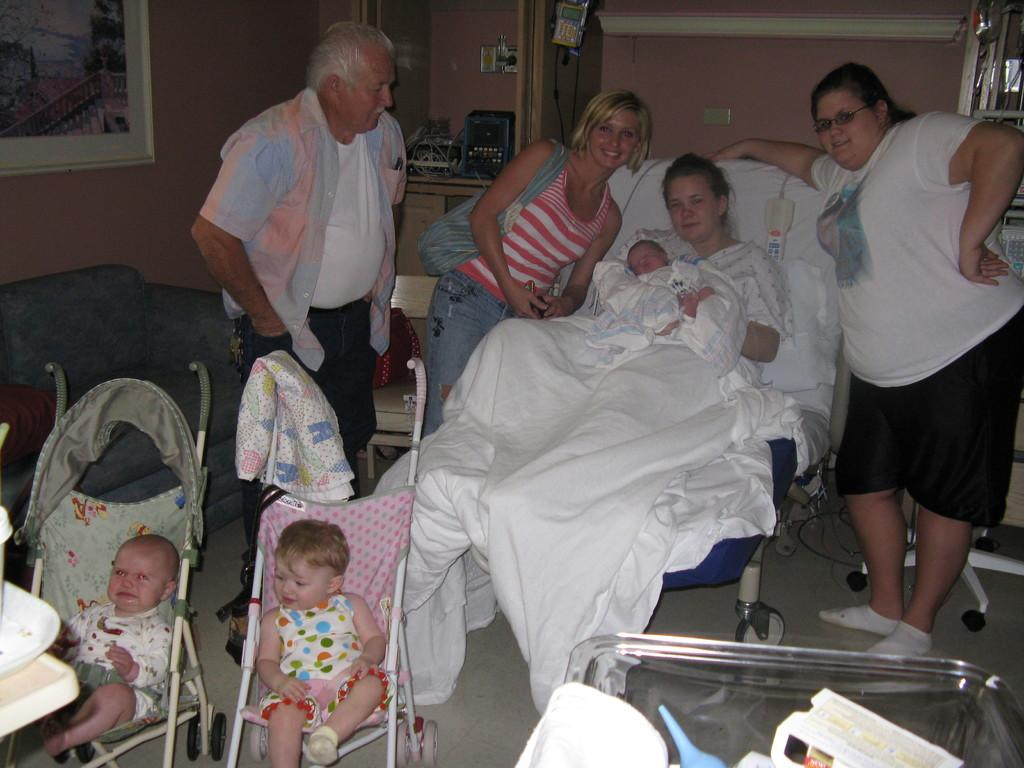What are the babies doing in the image? The babies are sitting in a buggy in the image. What is the woman doing in the image? The woman is lying on a bed and holding a baby in her hand. Are there any other people present in the image? Yes, there are other people standing beside the woman. How many chickens are present in the image? There are no chickens present in the image. What type of cats can be seen playing with the babies in the image? There are no cats present in the image. 